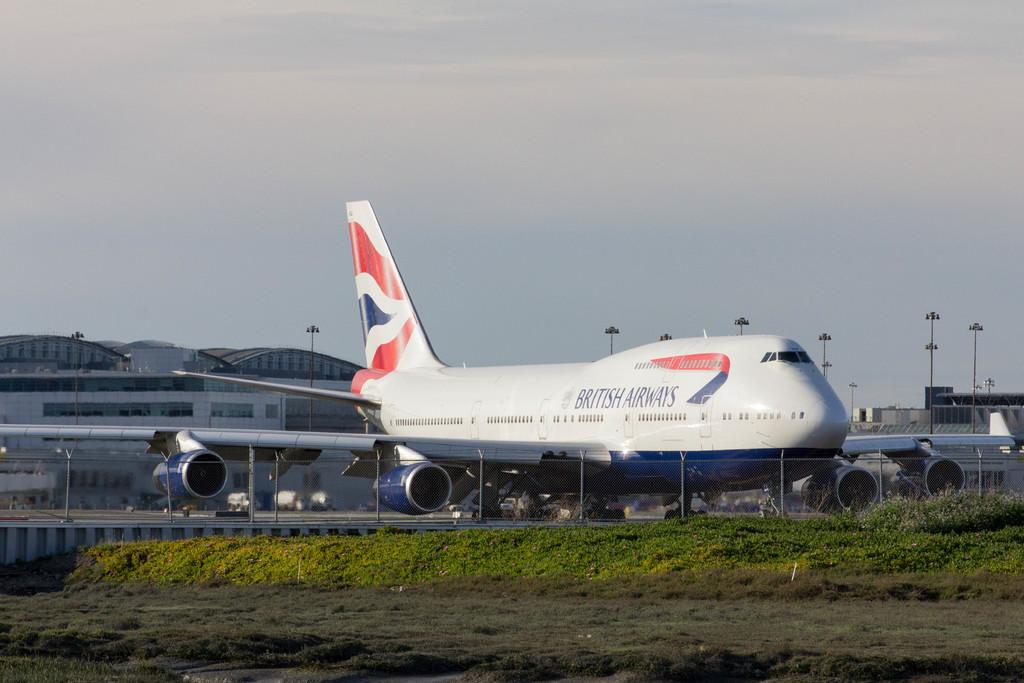<image>
Summarize the visual content of the image. A British Airways in front of a fence on the tarmac of an airport. 